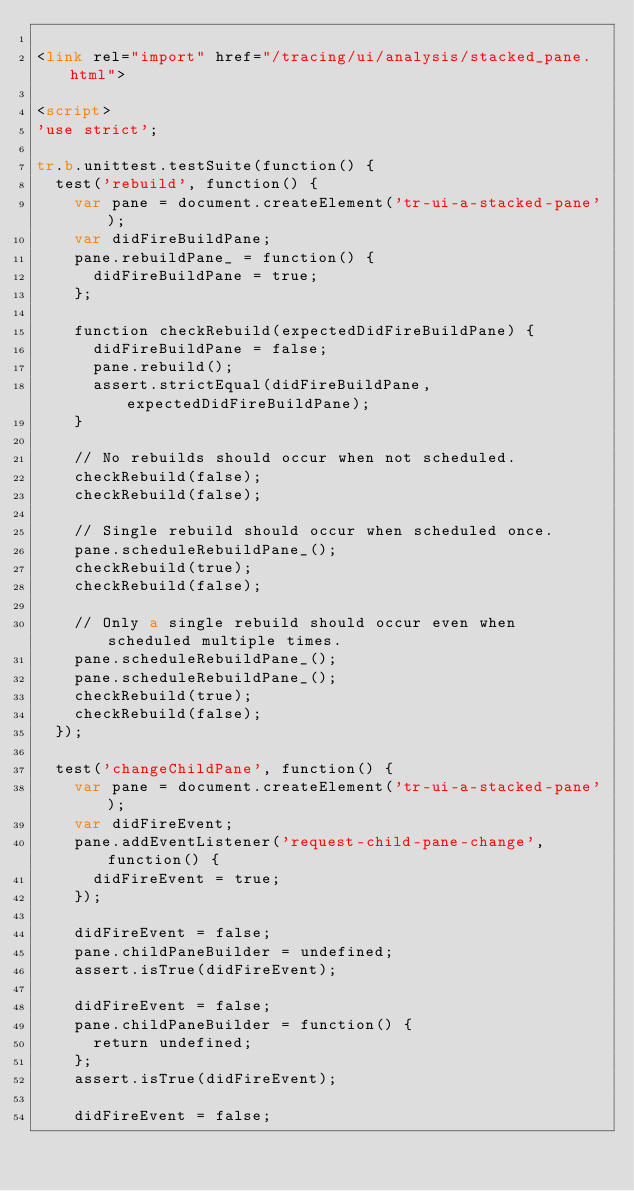<code> <loc_0><loc_0><loc_500><loc_500><_HTML_>
<link rel="import" href="/tracing/ui/analysis/stacked_pane.html">

<script>
'use strict';

tr.b.unittest.testSuite(function() {
  test('rebuild', function() {
    var pane = document.createElement('tr-ui-a-stacked-pane');
    var didFireBuildPane;
    pane.rebuildPane_ = function() {
      didFireBuildPane = true;
    };

    function checkRebuild(expectedDidFireBuildPane) {
      didFireBuildPane = false;
      pane.rebuild();
      assert.strictEqual(didFireBuildPane, expectedDidFireBuildPane);
    }

    // No rebuilds should occur when not scheduled.
    checkRebuild(false);
    checkRebuild(false);

    // Single rebuild should occur when scheduled once.
    pane.scheduleRebuildPane_();
    checkRebuild(true);
    checkRebuild(false);

    // Only a single rebuild should occur even when scheduled multiple times.
    pane.scheduleRebuildPane_();
    pane.scheduleRebuildPane_();
    checkRebuild(true);
    checkRebuild(false);
  });

  test('changeChildPane', function() {
    var pane = document.createElement('tr-ui-a-stacked-pane');
    var didFireEvent;
    pane.addEventListener('request-child-pane-change', function() {
      didFireEvent = true;
    });

    didFireEvent = false;
    pane.childPaneBuilder = undefined;
    assert.isTrue(didFireEvent);

    didFireEvent = false;
    pane.childPaneBuilder = function() {
      return undefined;
    };
    assert.isTrue(didFireEvent);

    didFireEvent = false;</code> 